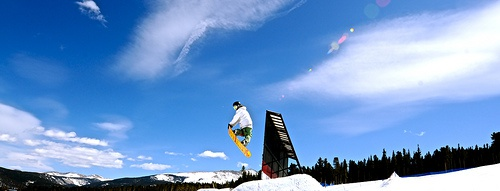Describe the objects in this image and their specific colors. I can see people in darkblue, lavender, black, darkgray, and gray tones and snowboard in darkblue, orange, and gold tones in this image. 